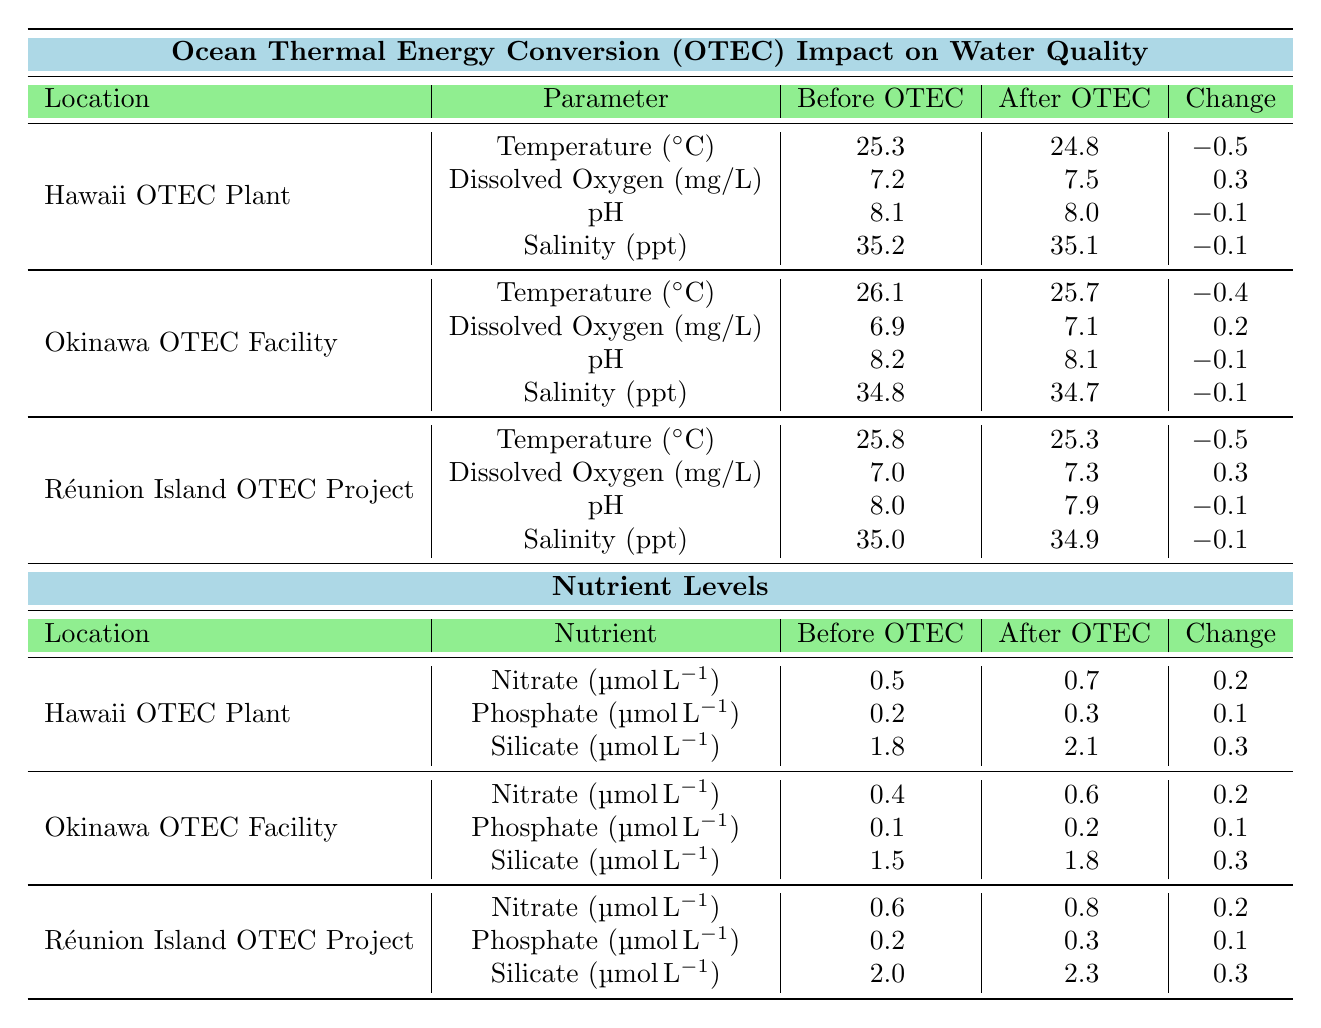What was the dissolved oxygen level before the OTEC implementation at the Hawaii OTEC Plant? According to the table, the dissolved oxygen level before OTEC at the Hawaii OTEC Plant is listed as 7.2 mg/L.
Answer: 7.2 mg/L What was the change in salinity after OTEC implementation in Okinawa? The table shows the before OTEC salinity in Okinawa as 34.8 ppt and after OTEC as 34.7 ppt. The change is 34.8 - 34.7 = -0.1 ppt.
Answer: -0.1 ppt Which location experienced the largest decrease in temperature after OTEC implementation? The changes in temperature after OTEC for each location are: Hawaii (-0.5 °C), Okinawa (-0.4 °C), and Réunion Island (-0.5 °C). Both Hawaii and Réunion Island experienced the largest decrease of -0.5 °C.
Answer: Hawaii and Réunion Island Was there an increase in nitrate levels at the Réunion Island OTEC Project after implementation? The nitrate level increased from 0.6 μmol/L before OTEC to 0.8 μmol/L after OTEC, indicating an increase.
Answer: Yes What is the average change in dissolved oxygen levels across all locations after OTEC implementation? The changes in dissolved oxygen levels are: Hawaii (0.3 mg/L), Okinawa (0.2 mg/L), and Réunion Island (0.3 mg/L). Their sum is 0.3 + 0.2 + 0.3 = 0.8 mg/L. Dividing by 3 (the number of locations) gives an average of 0.8 / 3 ≈ 0.267 mg/L.
Answer: 0.267 mg/L Did the pH level at any location remain the same after OTEC implementation? By reviewing the changes in pH levels: Hawaii (-0.1), Okinawa (-0.1), and Réunion Island (-0.1), it is clear that there were decreases at all locations, so none remained the same.
Answer: No Which nutrient showed the greatest change at the Hawaii OTEC Plant? The changes for nutrients at the Hawaii OTEC Plant are: Nitrate (0.2), Phosphate (0.1), and Silicate (0.3). Silicate had the greatest change of 0.3 μmol/L.
Answer: Silicate What was the total change in silicate levels across all three locations after OTEC? Before OTEC, the silicate levels were Hawaii (1.8), Okinawa (1.5), and Réunion Island (2.0), totaling 1.8 + 1.5 + 2.0 = 5.3 μmol/L. After OTEC, the total is 2.1 + 1.8 + 2.3 = 6.2 μmol/L. The total change is 6.2 - 5.3 = 0.9 μmol/L.
Answer: 0.9 μmol/L Did the Okinawa OTEC Facility have a higher dissolved oxygen level before or after the OTEC implementation? The table lists the dissolved oxygen level as 6.9 mg/L before OTEC and 7.1 mg/L after OTEC, showing it is higher after implementation.
Answer: After OTEC What can be inferred about the trend in salinity levels across all locations? Salinity levels decreased uniformly across all measured locations post-OTEC (Hawaii -0.1 ppt, Okinawa -0.1 ppt, Réunion Island -0.1 ppt), indicating a consistent trend of slight reduction.
Answer: Decrease in salinity levels across all locations 